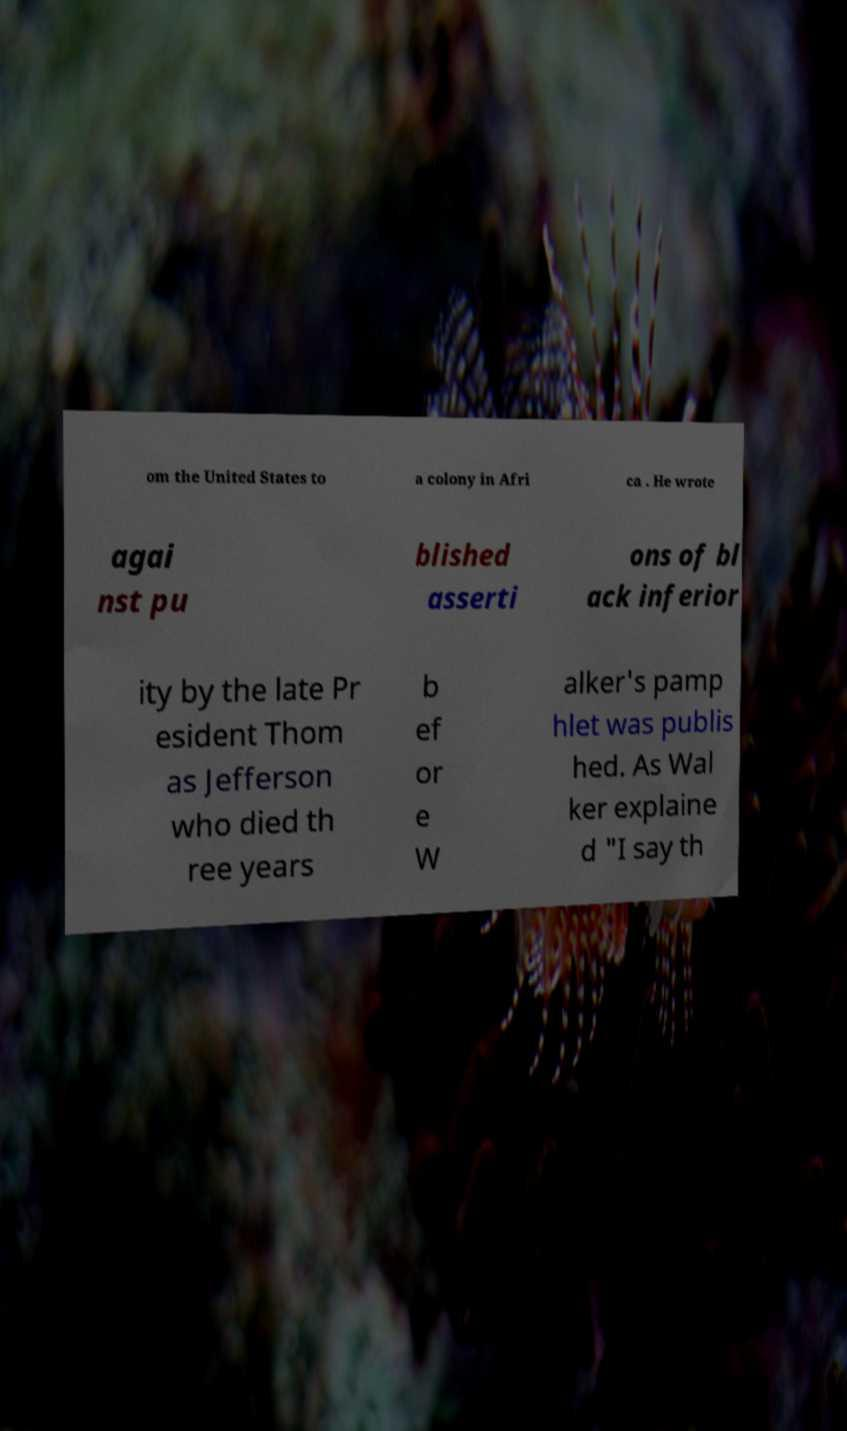There's text embedded in this image that I need extracted. Can you transcribe it verbatim? om the United States to a colony in Afri ca . He wrote agai nst pu blished asserti ons of bl ack inferior ity by the late Pr esident Thom as Jefferson who died th ree years b ef or e W alker's pamp hlet was publis hed. As Wal ker explaine d "I say th 